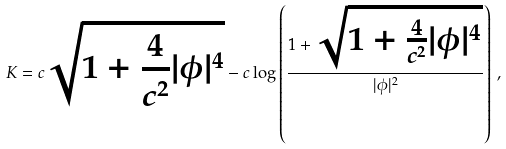Convert formula to latex. <formula><loc_0><loc_0><loc_500><loc_500>K = c \sqrt { 1 + { \frac { 4 } { c ^ { 2 } } } | \phi | ^ { 4 } } - c \log \left ( { \frac { 1 + \sqrt { 1 + { \frac { 4 } { c ^ { 2 } } } | \phi | ^ { 4 } } } { | \phi | ^ { 2 } } } \right ) \, ,</formula> 